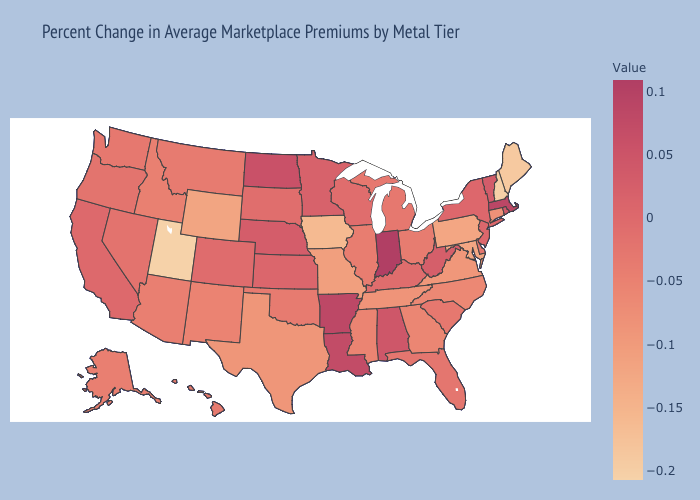Among the states that border Missouri , does Iowa have the lowest value?
Answer briefly. Yes. Does Indiana have the highest value in the MidWest?
Write a very short answer. Yes. Does New Jersey have the lowest value in the USA?
Short answer required. No. Which states have the lowest value in the West?
Keep it brief. Utah. 